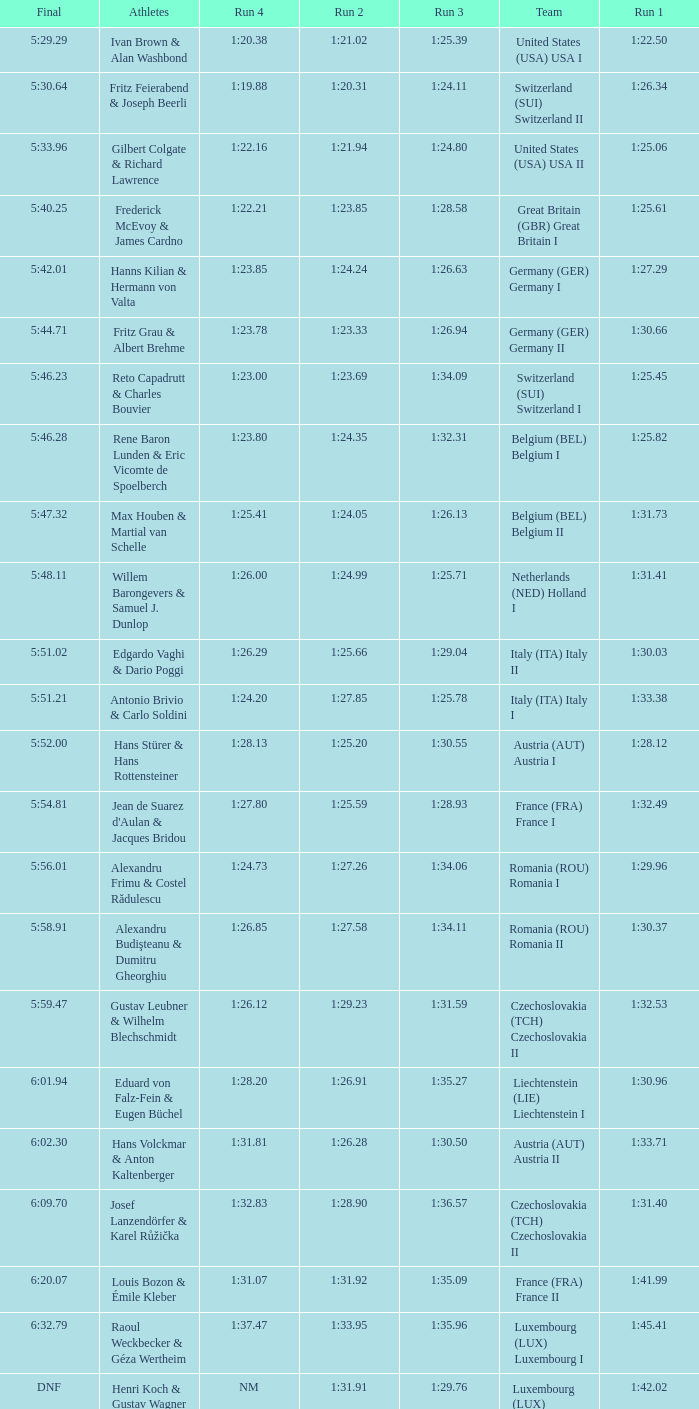Which Final has a Run 2 of 1:27.58? 5:58.91. Would you be able to parse every entry in this table? {'header': ['Final', 'Athletes', 'Run 4', 'Run 2', 'Run 3', 'Team', 'Run 1'], 'rows': [['5:29.29', 'Ivan Brown & Alan Washbond', '1:20.38', '1:21.02', '1:25.39', 'United States (USA) USA I', '1:22.50'], ['5:30.64', 'Fritz Feierabend & Joseph Beerli', '1:19.88', '1:20.31', '1:24.11', 'Switzerland (SUI) Switzerland II', '1:26.34'], ['5:33.96', 'Gilbert Colgate & Richard Lawrence', '1:22.16', '1:21.94', '1:24.80', 'United States (USA) USA II', '1:25.06'], ['5:40.25', 'Frederick McEvoy & James Cardno', '1:22.21', '1:23.85', '1:28.58', 'Great Britain (GBR) Great Britain I', '1:25.61'], ['5:42.01', 'Hanns Kilian & Hermann von Valta', '1:23.85', '1:24.24', '1:26.63', 'Germany (GER) Germany I', '1:27.29'], ['5:44.71', 'Fritz Grau & Albert Brehme', '1:23.78', '1:23.33', '1:26.94', 'Germany (GER) Germany II', '1:30.66'], ['5:46.23', 'Reto Capadrutt & Charles Bouvier', '1:23.00', '1:23.69', '1:34.09', 'Switzerland (SUI) Switzerland I', '1:25.45'], ['5:46.28', 'Rene Baron Lunden & Eric Vicomte de Spoelberch', '1:23.80', '1:24.35', '1:32.31', 'Belgium (BEL) Belgium I', '1:25.82'], ['5:47.32', 'Max Houben & Martial van Schelle', '1:25.41', '1:24.05', '1:26.13', 'Belgium (BEL) Belgium II', '1:31.73'], ['5:48.11', 'Willem Barongevers & Samuel J. Dunlop', '1:26.00', '1:24.99', '1:25.71', 'Netherlands (NED) Holland I', '1:31.41'], ['5:51.02', 'Edgardo Vaghi & Dario Poggi', '1:26.29', '1:25.66', '1:29.04', 'Italy (ITA) Italy II', '1:30.03'], ['5:51.21', 'Antonio Brivio & Carlo Soldini', '1:24.20', '1:27.85', '1:25.78', 'Italy (ITA) Italy I', '1:33.38'], ['5:52.00', 'Hans Stürer & Hans Rottensteiner', '1:28.13', '1:25.20', '1:30.55', 'Austria (AUT) Austria I', '1:28.12'], ['5:54.81', "Jean de Suarez d'Aulan & Jacques Bridou", '1:27.80', '1:25.59', '1:28.93', 'France (FRA) France I', '1:32.49'], ['5:56.01', 'Alexandru Frimu & Costel Rădulescu', '1:24.73', '1:27.26', '1:34.06', 'Romania (ROU) Romania I', '1:29.96'], ['5:58.91', 'Alexandru Budişteanu & Dumitru Gheorghiu', '1:26.85', '1:27.58', '1:34.11', 'Romania (ROU) Romania II', '1:30.37'], ['5:59.47', 'Gustav Leubner & Wilhelm Blechschmidt', '1:26.12', '1:29.23', '1:31.59', 'Czechoslovakia (TCH) Czechoslovakia II', '1:32.53'], ['6:01.94', 'Eduard von Falz-Fein & Eugen Büchel', '1:28.20', '1:26.91', '1:35.27', 'Liechtenstein (LIE) Liechtenstein I', '1:30.96'], ['6:02.30', 'Hans Volckmar & Anton Kaltenberger', '1:31.81', '1:26.28', '1:30.50', 'Austria (AUT) Austria II', '1:33.71'], ['6:09.70', 'Josef Lanzendörfer & Karel Růžička', '1:32.83', '1:28.90', '1:36.57', 'Czechoslovakia (TCH) Czechoslovakia II', '1:31.40'], ['6:20.07', 'Louis Bozon & Émile Kleber', '1:31.07', '1:31.92', '1:35.09', 'France (FRA) France II', '1:41.99'], ['6:32.79', 'Raoul Weckbecker & Géza Wertheim', '1:37.47', '1:33.95', '1:35.96', 'Luxembourg (LUX) Luxembourg I', '1:45.41'], ['DNF', 'Henri Koch & Gustav Wagner', 'NM', '1:31.91', '1:29.76', 'Luxembourg (LUX) Luxembourg II', '1:42.02']]} 